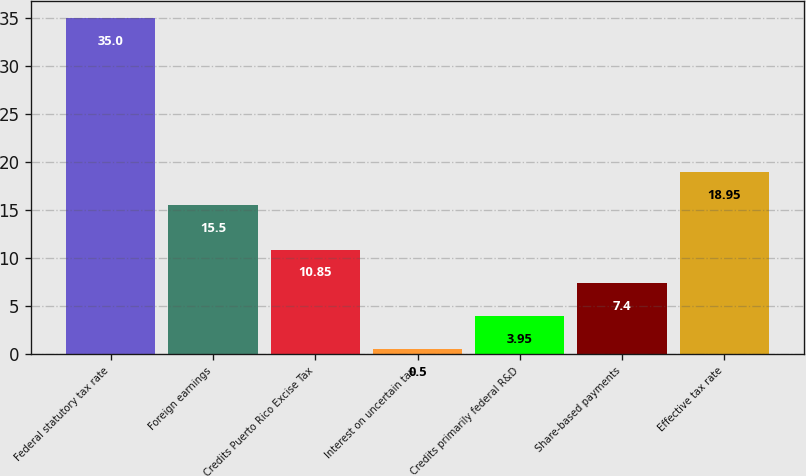<chart> <loc_0><loc_0><loc_500><loc_500><bar_chart><fcel>Federal statutory tax rate<fcel>Foreign earnings<fcel>Credits Puerto Rico Excise Tax<fcel>Interest on uncertain tax<fcel>Credits primarily federal R&D<fcel>Share-based payments<fcel>Effective tax rate<nl><fcel>35<fcel>15.5<fcel>10.85<fcel>0.5<fcel>3.95<fcel>7.4<fcel>18.95<nl></chart> 